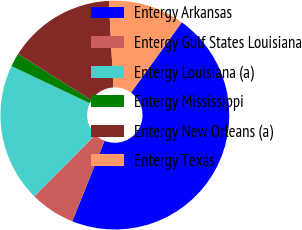Convert chart to OTSL. <chart><loc_0><loc_0><loc_500><loc_500><pie_chart><fcel>Entergy Arkansas<fcel>Entergy Gulf States Louisiana<fcel>Entergy Louisiana (a)<fcel>Entergy Mississippi<fcel>Entergy New Orleans (a)<fcel>Entergy Texas<nl><fcel>46.13%<fcel>6.36%<fcel>19.61%<fcel>1.94%<fcel>15.19%<fcel>10.77%<nl></chart> 